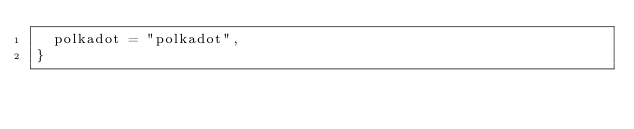<code> <loc_0><loc_0><loc_500><loc_500><_TypeScript_>  polkadot = "polkadot",
}
</code> 